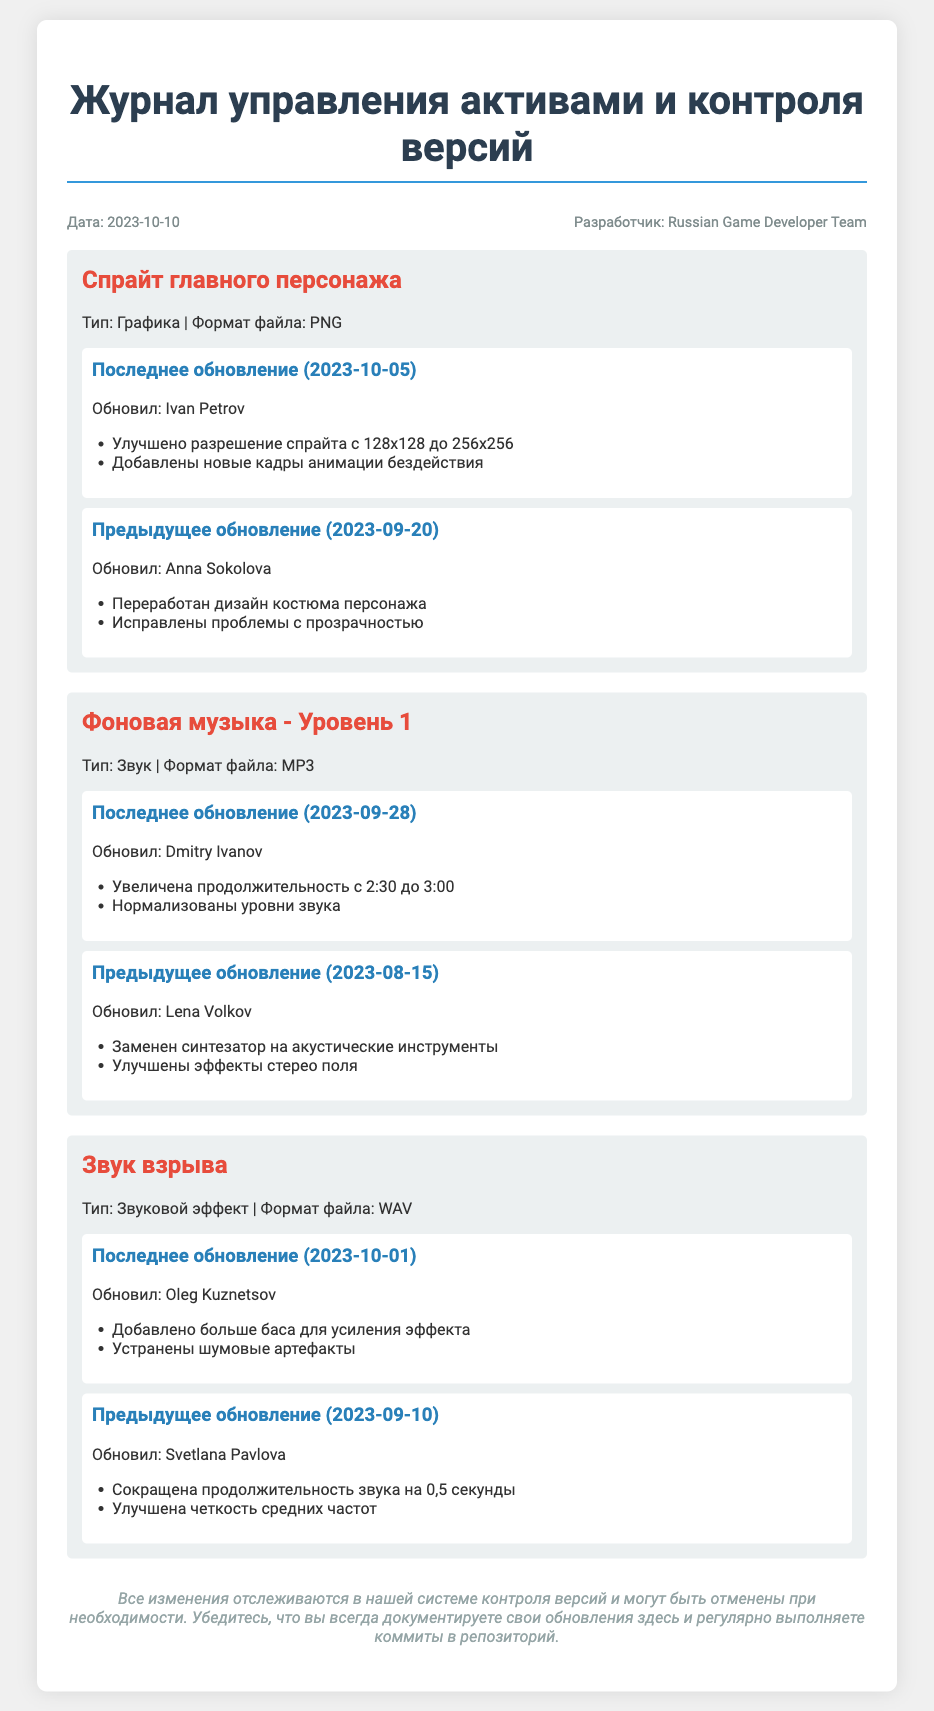Что было улучшено в спрайте главного персонажа? Улучшение разрешения спрайта с 128x128 до 256x256 и добавление новых кадров анимации бездействия.
Answer: Разрешение и анимация Когда было последнее обновление фоновой музыки? Дата последнего обновления фоновой музыки указана в соответствующей секции.
Answer: 2023-09-28 Кто обновил звук взрыва? Имя разработчика, который обновил звук взрыва, указано в разделе обновлений.
Answer: Oleg Kuznetsov Какова продолжительность фоновой музыки после последнего обновления? Продолжительность фоновой музыки указана в описании изменений.
Answer: 3:00 Кто был ответственен за переработку дизайна костюма главного персонажа? Имя разработчика, ответственного за данное изменение, указано в журнале.
Answer: Anna Sokolova Сколько раз обновлялся звук взрыва? Общее количество обновлений звука взрыва можно найти в секции обновлений.
Answer: 2 Какой формат файла у спрайта главного персонажа? Формат файла указан в описании актива.
Answer: PNG Нужен ли коммит в репозиторий после изменения? Ответ на этот вопрос основан на последних рекомендациях в документе.
Answer: Да 